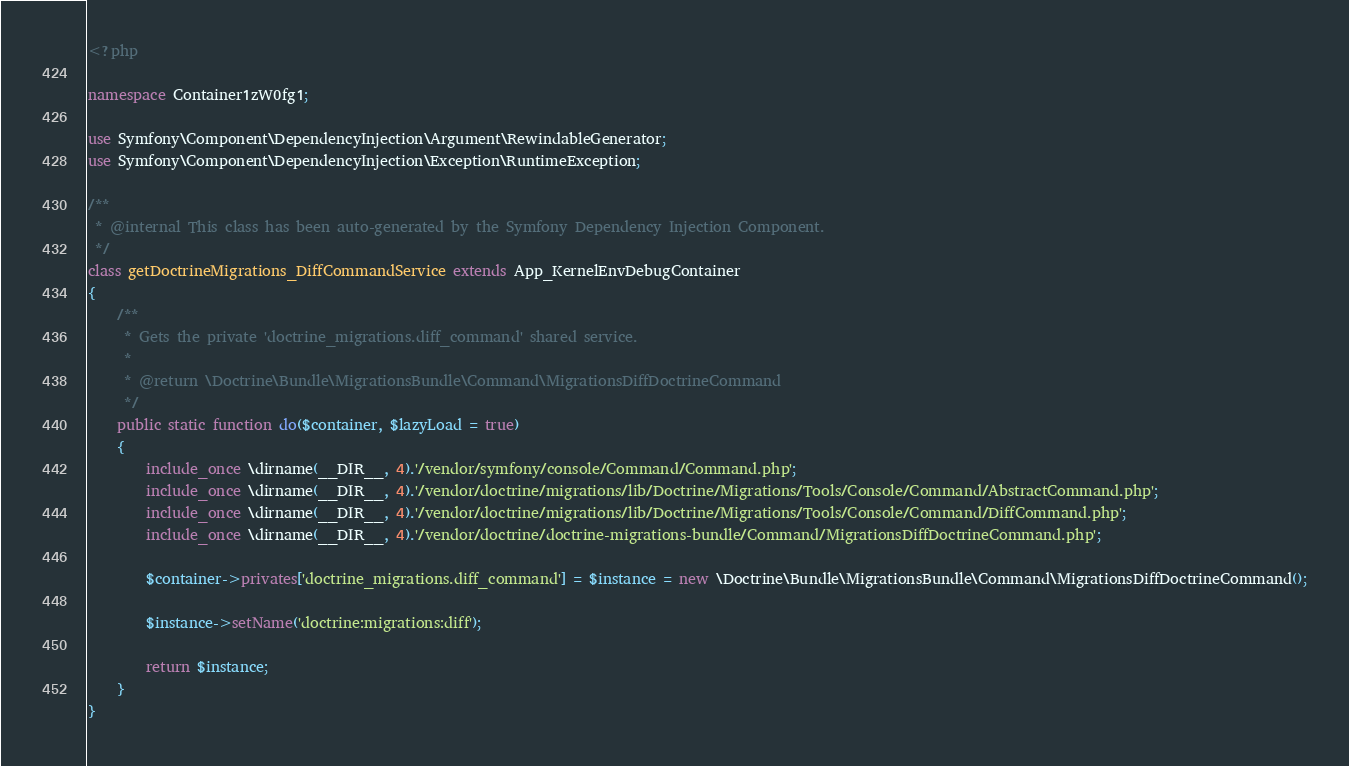Convert code to text. <code><loc_0><loc_0><loc_500><loc_500><_PHP_><?php

namespace Container1zW0fg1;

use Symfony\Component\DependencyInjection\Argument\RewindableGenerator;
use Symfony\Component\DependencyInjection\Exception\RuntimeException;

/**
 * @internal This class has been auto-generated by the Symfony Dependency Injection Component.
 */
class getDoctrineMigrations_DiffCommandService extends App_KernelEnvDebugContainer
{
    /**
     * Gets the private 'doctrine_migrations.diff_command' shared service.
     *
     * @return \Doctrine\Bundle\MigrationsBundle\Command\MigrationsDiffDoctrineCommand
     */
    public static function do($container, $lazyLoad = true)
    {
        include_once \dirname(__DIR__, 4).'/vendor/symfony/console/Command/Command.php';
        include_once \dirname(__DIR__, 4).'/vendor/doctrine/migrations/lib/Doctrine/Migrations/Tools/Console/Command/AbstractCommand.php';
        include_once \dirname(__DIR__, 4).'/vendor/doctrine/migrations/lib/Doctrine/Migrations/Tools/Console/Command/DiffCommand.php';
        include_once \dirname(__DIR__, 4).'/vendor/doctrine/doctrine-migrations-bundle/Command/MigrationsDiffDoctrineCommand.php';

        $container->privates['doctrine_migrations.diff_command'] = $instance = new \Doctrine\Bundle\MigrationsBundle\Command\MigrationsDiffDoctrineCommand();

        $instance->setName('doctrine:migrations:diff');

        return $instance;
    }
}
</code> 